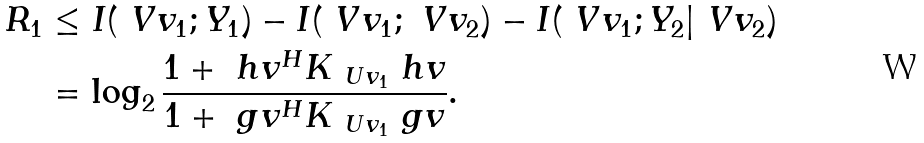<formula> <loc_0><loc_0><loc_500><loc_500>R _ { 1 } & \leq I ( \ V v _ { 1 } ; Y _ { 1 } ) - I ( \ V v _ { 1 } ; \ V v _ { 2 } ) - I ( \ V v _ { 1 } ; Y _ { 2 } | \ V v _ { 2 } ) \\ & = \log _ { 2 } \frac { 1 + \ h v ^ { H } K _ { \ U v _ { 1 } } \ h v } { 1 + \ g v ^ { H } K _ { \ U v _ { 1 } } \ g v } .</formula> 